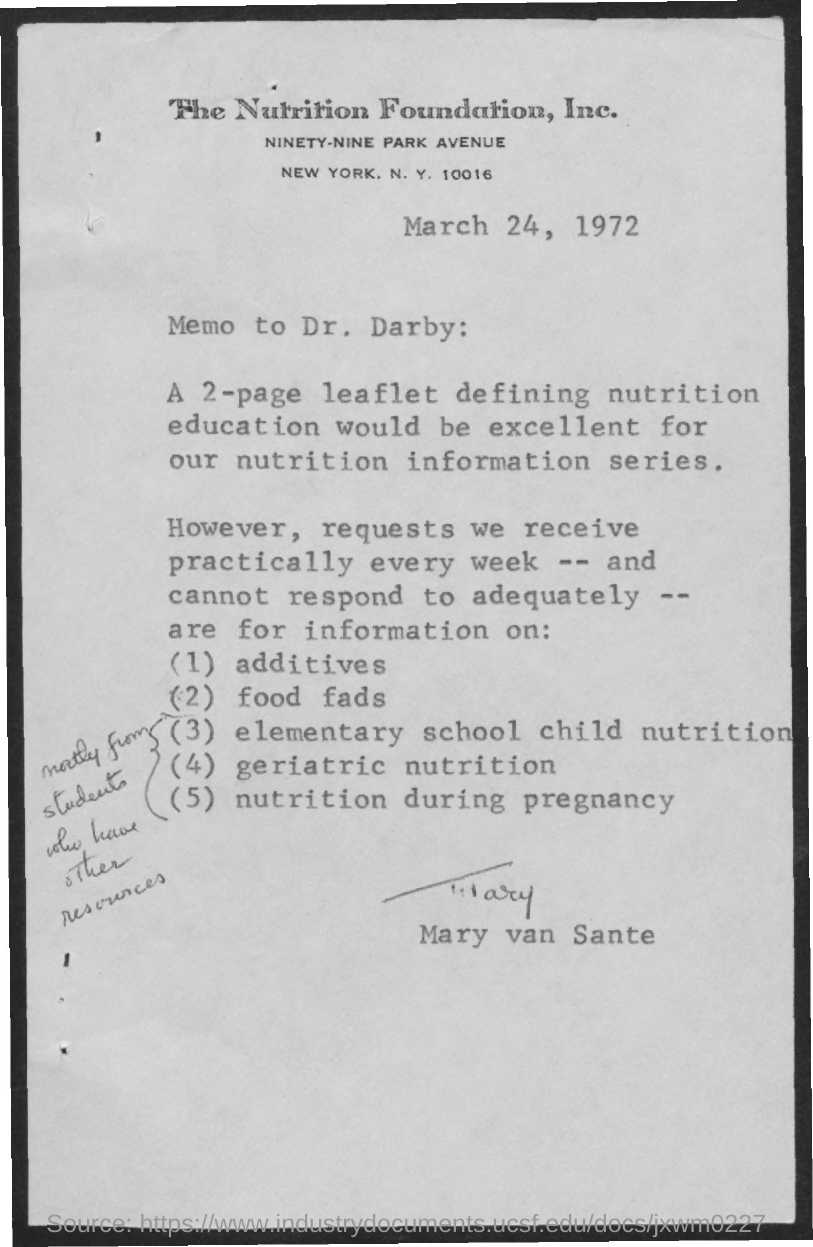Who sent the Memo?
Your answer should be very brief. Mary van Sante. Whom did  Mary sent the memo?
Provide a short and direct response. Dr. Darby. 